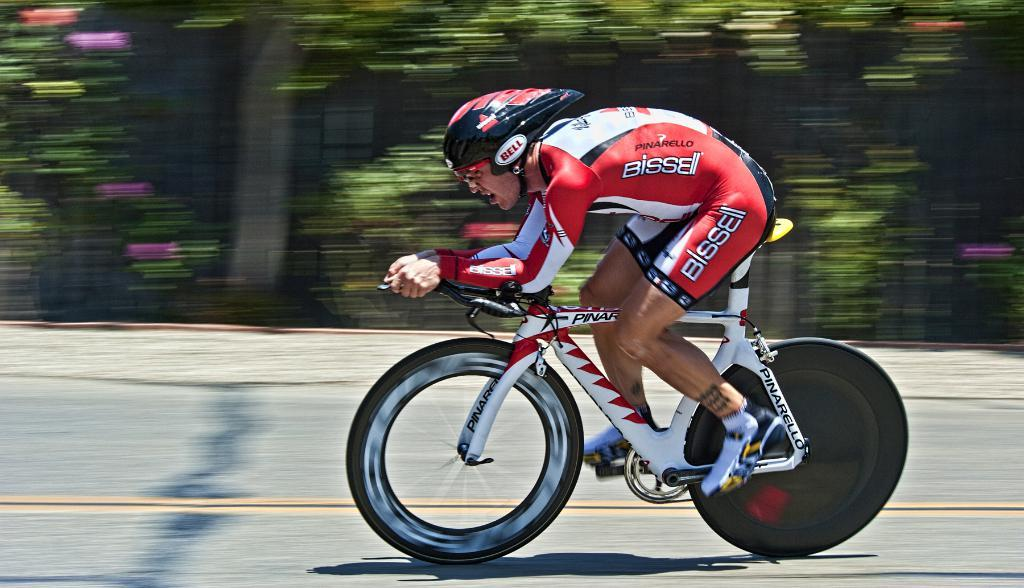Who is the person in the image? There is a man in the image. What is the man doing in the image? The man is riding a bicycle. Where is the man riding the bicycle? The man is on a road. What can be seen in the background of the image? There are trees in the background of the image. How many boys are present in the image? There is no boy present in the image; it features a man riding a bicycle. What is the elevation of the hill in the image? There is no hill present in the image; it features a man riding a bicycle on a road with trees in the background. 